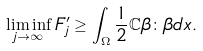Convert formula to latex. <formula><loc_0><loc_0><loc_500><loc_500>\liminf _ { j \to \infty } F _ { j } ^ { \prime } \geq \int _ { \Omega } \frac { 1 } { 2 } \mathbb { C } \beta \colon \beta d x .</formula> 